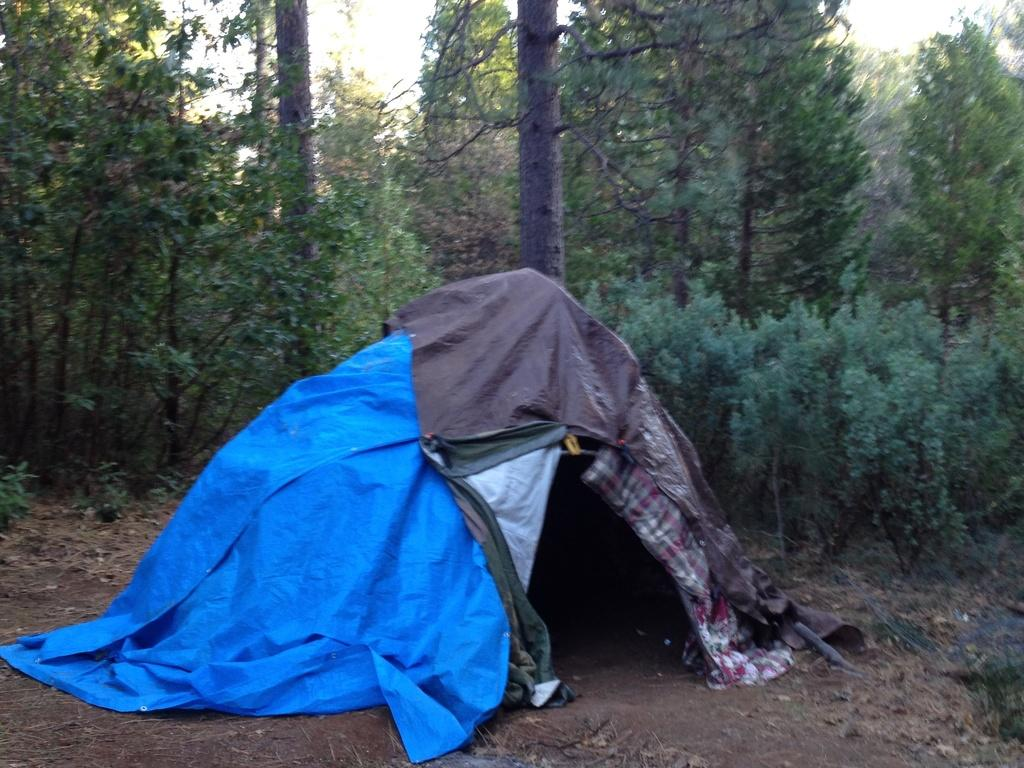What structure is visible in the image? There is a tent in the image. What can be seen in the background of the image? There are trees in the background of the image. What type of music can be heard coming from the hydrant in the image? There is no hydrant present in the image, so it's not possible to determine what, if any, music might be heard. 